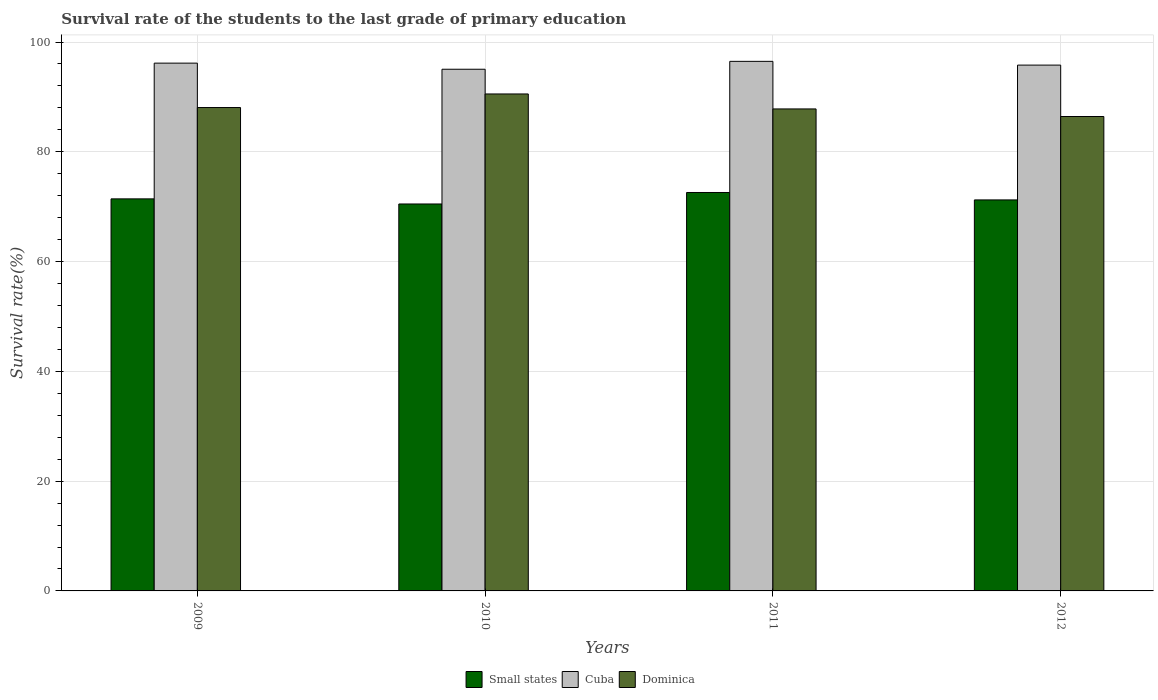Are the number of bars per tick equal to the number of legend labels?
Keep it short and to the point. Yes. Are the number of bars on each tick of the X-axis equal?
Your response must be concise. Yes. How many bars are there on the 1st tick from the left?
Keep it short and to the point. 3. What is the label of the 4th group of bars from the left?
Your answer should be compact. 2012. In how many cases, is the number of bars for a given year not equal to the number of legend labels?
Give a very brief answer. 0. What is the survival rate of the students in Dominica in 2012?
Provide a succinct answer. 86.43. Across all years, what is the maximum survival rate of the students in Dominica?
Offer a very short reply. 90.54. Across all years, what is the minimum survival rate of the students in Dominica?
Provide a succinct answer. 86.43. In which year was the survival rate of the students in Dominica maximum?
Your answer should be very brief. 2010. What is the total survival rate of the students in Cuba in the graph?
Ensure brevity in your answer.  383.46. What is the difference between the survival rate of the students in Dominica in 2011 and that in 2012?
Provide a short and direct response. 1.38. What is the difference between the survival rate of the students in Dominica in 2011 and the survival rate of the students in Small states in 2010?
Offer a terse response. 17.32. What is the average survival rate of the students in Cuba per year?
Offer a very short reply. 95.87. In the year 2012, what is the difference between the survival rate of the students in Cuba and survival rate of the students in Dominica?
Make the answer very short. 9.36. What is the ratio of the survival rate of the students in Dominica in 2009 to that in 2012?
Give a very brief answer. 1.02. Is the difference between the survival rate of the students in Cuba in 2010 and 2012 greater than the difference between the survival rate of the students in Dominica in 2010 and 2012?
Your response must be concise. No. What is the difference between the highest and the second highest survival rate of the students in Small states?
Offer a very short reply. 1.16. What is the difference between the highest and the lowest survival rate of the students in Small states?
Offer a terse response. 2.09. What does the 3rd bar from the left in 2010 represents?
Ensure brevity in your answer.  Dominica. What does the 2nd bar from the right in 2009 represents?
Provide a short and direct response. Cuba. Is it the case that in every year, the sum of the survival rate of the students in Cuba and survival rate of the students in Dominica is greater than the survival rate of the students in Small states?
Provide a succinct answer. Yes. How many bars are there?
Your answer should be compact. 12. Are all the bars in the graph horizontal?
Your answer should be very brief. No. How many years are there in the graph?
Give a very brief answer. 4. Are the values on the major ticks of Y-axis written in scientific E-notation?
Your response must be concise. No. Does the graph contain any zero values?
Your response must be concise. No. How many legend labels are there?
Your answer should be compact. 3. What is the title of the graph?
Keep it short and to the point. Survival rate of the students to the last grade of primary education. Does "Singapore" appear as one of the legend labels in the graph?
Ensure brevity in your answer.  No. What is the label or title of the Y-axis?
Give a very brief answer. Survival rate(%). What is the Survival rate(%) in Small states in 2009?
Offer a very short reply. 71.42. What is the Survival rate(%) in Cuba in 2009?
Ensure brevity in your answer.  96.15. What is the Survival rate(%) of Dominica in 2009?
Provide a succinct answer. 88.06. What is the Survival rate(%) of Small states in 2010?
Make the answer very short. 70.49. What is the Survival rate(%) in Cuba in 2010?
Give a very brief answer. 95.04. What is the Survival rate(%) in Dominica in 2010?
Provide a short and direct response. 90.54. What is the Survival rate(%) of Small states in 2011?
Provide a succinct answer. 72.58. What is the Survival rate(%) in Cuba in 2011?
Offer a terse response. 96.48. What is the Survival rate(%) of Dominica in 2011?
Your answer should be compact. 87.81. What is the Survival rate(%) of Small states in 2012?
Ensure brevity in your answer.  71.23. What is the Survival rate(%) in Cuba in 2012?
Provide a succinct answer. 95.79. What is the Survival rate(%) in Dominica in 2012?
Keep it short and to the point. 86.43. Across all years, what is the maximum Survival rate(%) of Small states?
Provide a succinct answer. 72.58. Across all years, what is the maximum Survival rate(%) of Cuba?
Your answer should be compact. 96.48. Across all years, what is the maximum Survival rate(%) of Dominica?
Your response must be concise. 90.54. Across all years, what is the minimum Survival rate(%) in Small states?
Give a very brief answer. 70.49. Across all years, what is the minimum Survival rate(%) in Cuba?
Keep it short and to the point. 95.04. Across all years, what is the minimum Survival rate(%) of Dominica?
Make the answer very short. 86.43. What is the total Survival rate(%) in Small states in the graph?
Provide a succinct answer. 285.74. What is the total Survival rate(%) of Cuba in the graph?
Your answer should be very brief. 383.46. What is the total Survival rate(%) in Dominica in the graph?
Make the answer very short. 352.84. What is the difference between the Survival rate(%) in Small states in 2009 and that in 2010?
Make the answer very short. 0.93. What is the difference between the Survival rate(%) in Cuba in 2009 and that in 2010?
Make the answer very short. 1.11. What is the difference between the Survival rate(%) in Dominica in 2009 and that in 2010?
Ensure brevity in your answer.  -2.47. What is the difference between the Survival rate(%) of Small states in 2009 and that in 2011?
Make the answer very short. -1.16. What is the difference between the Survival rate(%) in Cuba in 2009 and that in 2011?
Offer a terse response. -0.32. What is the difference between the Survival rate(%) of Dominica in 2009 and that in 2011?
Offer a very short reply. 0.25. What is the difference between the Survival rate(%) of Small states in 2009 and that in 2012?
Your response must be concise. 0.19. What is the difference between the Survival rate(%) of Cuba in 2009 and that in 2012?
Your response must be concise. 0.36. What is the difference between the Survival rate(%) of Dominica in 2009 and that in 2012?
Provide a short and direct response. 1.63. What is the difference between the Survival rate(%) in Small states in 2010 and that in 2011?
Your answer should be compact. -2.09. What is the difference between the Survival rate(%) in Cuba in 2010 and that in 2011?
Offer a terse response. -1.44. What is the difference between the Survival rate(%) of Dominica in 2010 and that in 2011?
Offer a terse response. 2.73. What is the difference between the Survival rate(%) of Small states in 2010 and that in 2012?
Your answer should be compact. -0.74. What is the difference between the Survival rate(%) of Cuba in 2010 and that in 2012?
Give a very brief answer. -0.75. What is the difference between the Survival rate(%) of Dominica in 2010 and that in 2012?
Your answer should be compact. 4.11. What is the difference between the Survival rate(%) in Small states in 2011 and that in 2012?
Keep it short and to the point. 1.35. What is the difference between the Survival rate(%) of Cuba in 2011 and that in 2012?
Provide a short and direct response. 0.68. What is the difference between the Survival rate(%) of Dominica in 2011 and that in 2012?
Provide a succinct answer. 1.38. What is the difference between the Survival rate(%) in Small states in 2009 and the Survival rate(%) in Cuba in 2010?
Make the answer very short. -23.62. What is the difference between the Survival rate(%) in Small states in 2009 and the Survival rate(%) in Dominica in 2010?
Your answer should be very brief. -19.11. What is the difference between the Survival rate(%) of Cuba in 2009 and the Survival rate(%) of Dominica in 2010?
Keep it short and to the point. 5.61. What is the difference between the Survival rate(%) in Small states in 2009 and the Survival rate(%) in Cuba in 2011?
Offer a terse response. -25.05. What is the difference between the Survival rate(%) of Small states in 2009 and the Survival rate(%) of Dominica in 2011?
Offer a terse response. -16.39. What is the difference between the Survival rate(%) of Cuba in 2009 and the Survival rate(%) of Dominica in 2011?
Ensure brevity in your answer.  8.34. What is the difference between the Survival rate(%) in Small states in 2009 and the Survival rate(%) in Cuba in 2012?
Your response must be concise. -24.37. What is the difference between the Survival rate(%) in Small states in 2009 and the Survival rate(%) in Dominica in 2012?
Provide a succinct answer. -15.01. What is the difference between the Survival rate(%) in Cuba in 2009 and the Survival rate(%) in Dominica in 2012?
Your response must be concise. 9.72. What is the difference between the Survival rate(%) in Small states in 2010 and the Survival rate(%) in Cuba in 2011?
Keep it short and to the point. -25.98. What is the difference between the Survival rate(%) of Small states in 2010 and the Survival rate(%) of Dominica in 2011?
Make the answer very short. -17.32. What is the difference between the Survival rate(%) in Cuba in 2010 and the Survival rate(%) in Dominica in 2011?
Offer a very short reply. 7.23. What is the difference between the Survival rate(%) in Small states in 2010 and the Survival rate(%) in Cuba in 2012?
Make the answer very short. -25.3. What is the difference between the Survival rate(%) in Small states in 2010 and the Survival rate(%) in Dominica in 2012?
Offer a very short reply. -15.94. What is the difference between the Survival rate(%) in Cuba in 2010 and the Survival rate(%) in Dominica in 2012?
Your answer should be very brief. 8.61. What is the difference between the Survival rate(%) in Small states in 2011 and the Survival rate(%) in Cuba in 2012?
Your answer should be compact. -23.21. What is the difference between the Survival rate(%) in Small states in 2011 and the Survival rate(%) in Dominica in 2012?
Provide a succinct answer. -13.85. What is the difference between the Survival rate(%) in Cuba in 2011 and the Survival rate(%) in Dominica in 2012?
Make the answer very short. 10.05. What is the average Survival rate(%) in Small states per year?
Your response must be concise. 71.43. What is the average Survival rate(%) in Cuba per year?
Ensure brevity in your answer.  95.87. What is the average Survival rate(%) of Dominica per year?
Ensure brevity in your answer.  88.21. In the year 2009, what is the difference between the Survival rate(%) of Small states and Survival rate(%) of Cuba?
Make the answer very short. -24.73. In the year 2009, what is the difference between the Survival rate(%) of Small states and Survival rate(%) of Dominica?
Provide a short and direct response. -16.64. In the year 2009, what is the difference between the Survival rate(%) of Cuba and Survival rate(%) of Dominica?
Your answer should be compact. 8.09. In the year 2010, what is the difference between the Survival rate(%) in Small states and Survival rate(%) in Cuba?
Your response must be concise. -24.55. In the year 2010, what is the difference between the Survival rate(%) in Small states and Survival rate(%) in Dominica?
Ensure brevity in your answer.  -20.05. In the year 2010, what is the difference between the Survival rate(%) in Cuba and Survival rate(%) in Dominica?
Provide a succinct answer. 4.5. In the year 2011, what is the difference between the Survival rate(%) of Small states and Survival rate(%) of Cuba?
Keep it short and to the point. -23.89. In the year 2011, what is the difference between the Survival rate(%) in Small states and Survival rate(%) in Dominica?
Give a very brief answer. -15.22. In the year 2011, what is the difference between the Survival rate(%) in Cuba and Survival rate(%) in Dominica?
Provide a short and direct response. 8.67. In the year 2012, what is the difference between the Survival rate(%) in Small states and Survival rate(%) in Cuba?
Give a very brief answer. -24.56. In the year 2012, what is the difference between the Survival rate(%) in Small states and Survival rate(%) in Dominica?
Offer a terse response. -15.2. In the year 2012, what is the difference between the Survival rate(%) of Cuba and Survival rate(%) of Dominica?
Offer a very short reply. 9.36. What is the ratio of the Survival rate(%) of Small states in 2009 to that in 2010?
Provide a short and direct response. 1.01. What is the ratio of the Survival rate(%) of Cuba in 2009 to that in 2010?
Your response must be concise. 1.01. What is the ratio of the Survival rate(%) of Dominica in 2009 to that in 2010?
Ensure brevity in your answer.  0.97. What is the ratio of the Survival rate(%) of Small states in 2009 to that in 2011?
Give a very brief answer. 0.98. What is the ratio of the Survival rate(%) of Cuba in 2009 to that in 2011?
Provide a short and direct response. 1. What is the ratio of the Survival rate(%) of Small states in 2009 to that in 2012?
Keep it short and to the point. 1. What is the ratio of the Survival rate(%) in Dominica in 2009 to that in 2012?
Your answer should be very brief. 1.02. What is the ratio of the Survival rate(%) of Small states in 2010 to that in 2011?
Keep it short and to the point. 0.97. What is the ratio of the Survival rate(%) in Cuba in 2010 to that in 2011?
Your response must be concise. 0.99. What is the ratio of the Survival rate(%) of Dominica in 2010 to that in 2011?
Keep it short and to the point. 1.03. What is the ratio of the Survival rate(%) in Small states in 2010 to that in 2012?
Offer a very short reply. 0.99. What is the ratio of the Survival rate(%) of Dominica in 2010 to that in 2012?
Give a very brief answer. 1.05. What is the ratio of the Survival rate(%) in Small states in 2011 to that in 2012?
Ensure brevity in your answer.  1.02. What is the ratio of the Survival rate(%) of Cuba in 2011 to that in 2012?
Offer a very short reply. 1.01. What is the difference between the highest and the second highest Survival rate(%) in Small states?
Offer a very short reply. 1.16. What is the difference between the highest and the second highest Survival rate(%) in Cuba?
Provide a short and direct response. 0.32. What is the difference between the highest and the second highest Survival rate(%) in Dominica?
Offer a terse response. 2.47. What is the difference between the highest and the lowest Survival rate(%) in Small states?
Make the answer very short. 2.09. What is the difference between the highest and the lowest Survival rate(%) in Cuba?
Your answer should be very brief. 1.44. What is the difference between the highest and the lowest Survival rate(%) of Dominica?
Offer a very short reply. 4.11. 